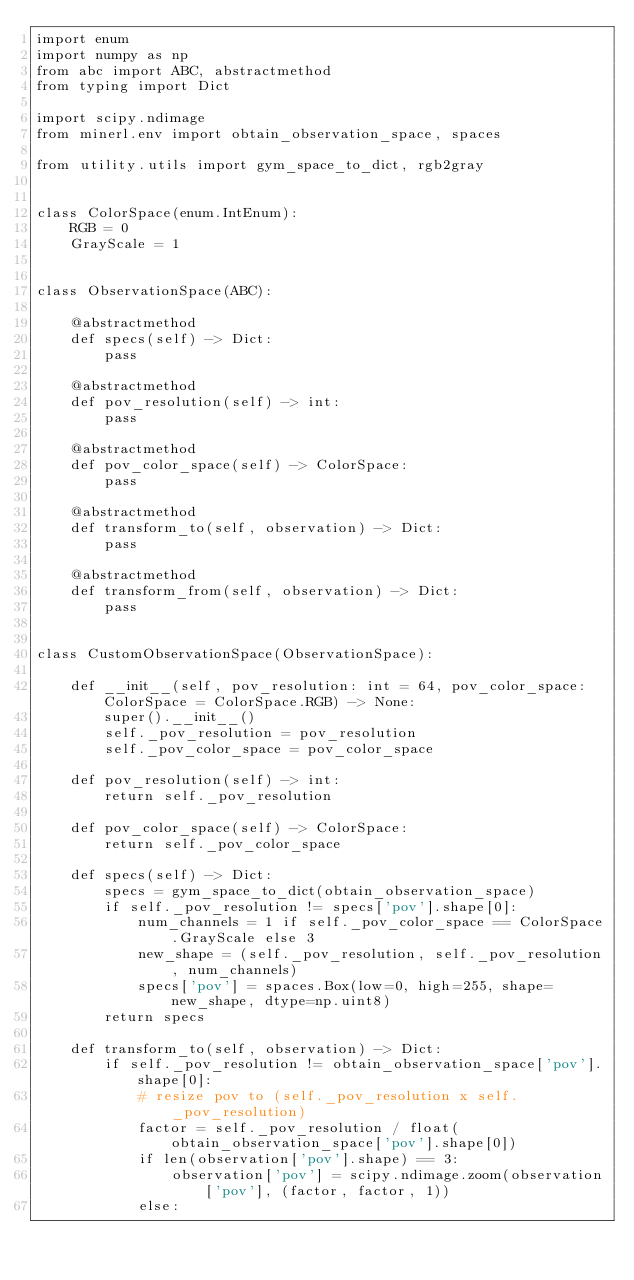Convert code to text. <code><loc_0><loc_0><loc_500><loc_500><_Python_>import enum
import numpy as np
from abc import ABC, abstractmethod
from typing import Dict

import scipy.ndimage
from minerl.env import obtain_observation_space, spaces

from utility.utils import gym_space_to_dict, rgb2gray


class ColorSpace(enum.IntEnum):
    RGB = 0
    GrayScale = 1


class ObservationSpace(ABC):

    @abstractmethod
    def specs(self) -> Dict:
        pass

    @abstractmethod
    def pov_resolution(self) -> int:
        pass

    @abstractmethod
    def pov_color_space(self) -> ColorSpace:
        pass

    @abstractmethod
    def transform_to(self, observation) -> Dict:
        pass

    @abstractmethod
    def transform_from(self, observation) -> Dict:
        pass


class CustomObservationSpace(ObservationSpace):

    def __init__(self, pov_resolution: int = 64, pov_color_space: ColorSpace = ColorSpace.RGB) -> None:
        super().__init__()
        self._pov_resolution = pov_resolution
        self._pov_color_space = pov_color_space

    def pov_resolution(self) -> int:
        return self._pov_resolution

    def pov_color_space(self) -> ColorSpace:
        return self._pov_color_space

    def specs(self) -> Dict:
        specs = gym_space_to_dict(obtain_observation_space)
        if self._pov_resolution != specs['pov'].shape[0]:
            num_channels = 1 if self._pov_color_space == ColorSpace.GrayScale else 3
            new_shape = (self._pov_resolution, self._pov_resolution, num_channels)
            specs['pov'] = spaces.Box(low=0, high=255, shape=new_shape, dtype=np.uint8)
        return specs

    def transform_to(self, observation) -> Dict:
        if self._pov_resolution != obtain_observation_space['pov'].shape[0]:
            # resize pov to (self._pov_resolution x self._pov_resolution)
            factor = self._pov_resolution / float(obtain_observation_space['pov'].shape[0])
            if len(observation['pov'].shape) == 3:
                observation['pov'] = scipy.ndimage.zoom(observation['pov'], (factor, factor, 1))
            else:</code> 